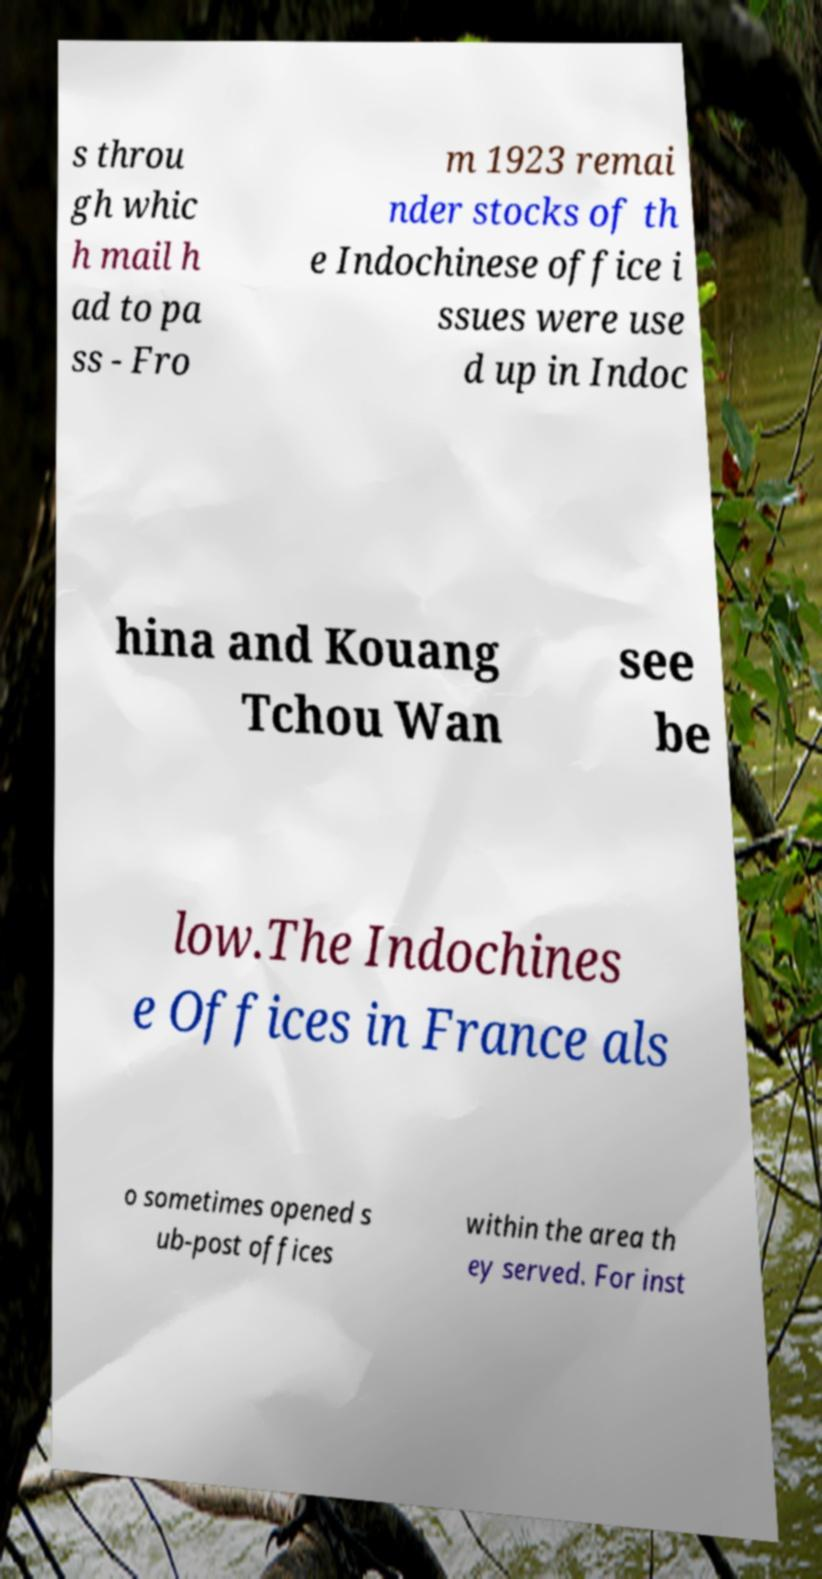Please read and relay the text visible in this image. What does it say? s throu gh whic h mail h ad to pa ss - Fro m 1923 remai nder stocks of th e Indochinese office i ssues were use d up in Indoc hina and Kouang Tchou Wan see be low.The Indochines e Offices in France als o sometimes opened s ub-post offices within the area th ey served. For inst 